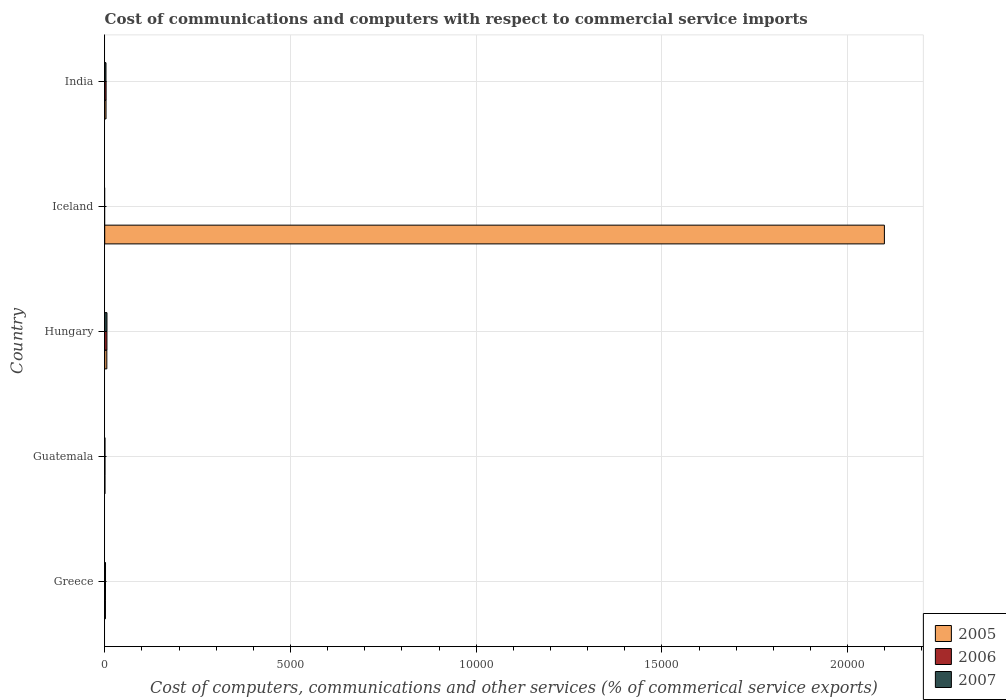How many different coloured bars are there?
Your response must be concise. 3. What is the label of the 3rd group of bars from the top?
Make the answer very short. Hungary. In how many cases, is the number of bars for a given country not equal to the number of legend labels?
Your answer should be compact. 1. What is the cost of communications and computers in 2005 in Greece?
Ensure brevity in your answer.  19.54. Across all countries, what is the maximum cost of communications and computers in 2007?
Provide a short and direct response. 60.46. Across all countries, what is the minimum cost of communications and computers in 2005?
Provide a succinct answer. 5.89. In which country was the cost of communications and computers in 2007 maximum?
Your answer should be very brief. Hungary. What is the total cost of communications and computers in 2005 in the graph?
Keep it short and to the point. 2.11e+04. What is the difference between the cost of communications and computers in 2007 in Greece and that in India?
Provide a succinct answer. -12.91. What is the difference between the cost of communications and computers in 2005 in India and the cost of communications and computers in 2007 in Greece?
Make the answer very short. 13.91. What is the average cost of communications and computers in 2007 per country?
Provide a succinct answer. 24.45. What is the difference between the cost of communications and computers in 2006 and cost of communications and computers in 2005 in Hungary?
Give a very brief answer. 3.06. What is the ratio of the cost of communications and computers in 2005 in Hungary to that in Iceland?
Your answer should be compact. 0. Is the cost of communications and computers in 2005 in Iceland less than that in India?
Offer a very short reply. No. Is the difference between the cost of communications and computers in 2006 in Greece and Hungary greater than the difference between the cost of communications and computers in 2005 in Greece and Hungary?
Provide a short and direct response. No. What is the difference between the highest and the second highest cost of communications and computers in 2006?
Your answer should be very brief. 22.77. What is the difference between the highest and the lowest cost of communications and computers in 2007?
Your response must be concise. 60.46. In how many countries, is the cost of communications and computers in 2007 greater than the average cost of communications and computers in 2007 taken over all countries?
Make the answer very short. 2. Is the sum of the cost of communications and computers in 2006 in Greece and India greater than the maximum cost of communications and computers in 2005 across all countries?
Ensure brevity in your answer.  No. Are all the bars in the graph horizontal?
Your answer should be compact. Yes. What is the difference between two consecutive major ticks on the X-axis?
Make the answer very short. 5000. Does the graph contain any zero values?
Your answer should be compact. Yes. Does the graph contain grids?
Offer a terse response. Yes. Where does the legend appear in the graph?
Your answer should be very brief. Bottom right. How are the legend labels stacked?
Your response must be concise. Vertical. What is the title of the graph?
Give a very brief answer. Cost of communications and computers with respect to commercial service imports. What is the label or title of the X-axis?
Offer a terse response. Cost of computers, communications and other services (% of commerical service exports). What is the label or title of the Y-axis?
Keep it short and to the point. Country. What is the Cost of computers, communications and other services (% of commerical service exports) in 2005 in Greece?
Offer a very short reply. 19.54. What is the Cost of computers, communications and other services (% of commerical service exports) in 2006 in Greece?
Keep it short and to the point. 20.81. What is the Cost of computers, communications and other services (% of commerical service exports) of 2007 in Greece?
Make the answer very short. 21.27. What is the Cost of computers, communications and other services (% of commerical service exports) of 2005 in Guatemala?
Give a very brief answer. 5.89. What is the Cost of computers, communications and other services (% of commerical service exports) of 2006 in Guatemala?
Provide a succinct answer. 6.58. What is the Cost of computers, communications and other services (% of commerical service exports) in 2007 in Guatemala?
Your answer should be compact. 6.34. What is the Cost of computers, communications and other services (% of commerical service exports) in 2005 in Hungary?
Your response must be concise. 56.61. What is the Cost of computers, communications and other services (% of commerical service exports) in 2006 in Hungary?
Offer a terse response. 59.67. What is the Cost of computers, communications and other services (% of commerical service exports) of 2007 in Hungary?
Offer a terse response. 60.46. What is the Cost of computers, communications and other services (% of commerical service exports) of 2005 in Iceland?
Your response must be concise. 2.10e+04. What is the Cost of computers, communications and other services (% of commerical service exports) in 2006 in Iceland?
Make the answer very short. 0. What is the Cost of computers, communications and other services (% of commerical service exports) in 2007 in Iceland?
Provide a succinct answer. 0. What is the Cost of computers, communications and other services (% of commerical service exports) in 2005 in India?
Your answer should be compact. 35.18. What is the Cost of computers, communications and other services (% of commerical service exports) in 2006 in India?
Provide a succinct answer. 36.9. What is the Cost of computers, communications and other services (% of commerical service exports) of 2007 in India?
Give a very brief answer. 34.18. Across all countries, what is the maximum Cost of computers, communications and other services (% of commerical service exports) of 2005?
Offer a terse response. 2.10e+04. Across all countries, what is the maximum Cost of computers, communications and other services (% of commerical service exports) in 2006?
Make the answer very short. 59.67. Across all countries, what is the maximum Cost of computers, communications and other services (% of commerical service exports) of 2007?
Your answer should be very brief. 60.46. Across all countries, what is the minimum Cost of computers, communications and other services (% of commerical service exports) in 2005?
Provide a succinct answer. 5.89. What is the total Cost of computers, communications and other services (% of commerical service exports) of 2005 in the graph?
Offer a terse response. 2.11e+04. What is the total Cost of computers, communications and other services (% of commerical service exports) of 2006 in the graph?
Offer a terse response. 123.96. What is the total Cost of computers, communications and other services (% of commerical service exports) of 2007 in the graph?
Keep it short and to the point. 122.25. What is the difference between the Cost of computers, communications and other services (% of commerical service exports) of 2005 in Greece and that in Guatemala?
Your answer should be very brief. 13.65. What is the difference between the Cost of computers, communications and other services (% of commerical service exports) in 2006 in Greece and that in Guatemala?
Provide a succinct answer. 14.23. What is the difference between the Cost of computers, communications and other services (% of commerical service exports) in 2007 in Greece and that in Guatemala?
Provide a short and direct response. 14.93. What is the difference between the Cost of computers, communications and other services (% of commerical service exports) in 2005 in Greece and that in Hungary?
Make the answer very short. -37.06. What is the difference between the Cost of computers, communications and other services (% of commerical service exports) of 2006 in Greece and that in Hungary?
Ensure brevity in your answer.  -38.86. What is the difference between the Cost of computers, communications and other services (% of commerical service exports) in 2007 in Greece and that in Hungary?
Keep it short and to the point. -39.19. What is the difference between the Cost of computers, communications and other services (% of commerical service exports) of 2005 in Greece and that in Iceland?
Ensure brevity in your answer.  -2.10e+04. What is the difference between the Cost of computers, communications and other services (% of commerical service exports) in 2005 in Greece and that in India?
Keep it short and to the point. -15.63. What is the difference between the Cost of computers, communications and other services (% of commerical service exports) in 2006 in Greece and that in India?
Ensure brevity in your answer.  -16.09. What is the difference between the Cost of computers, communications and other services (% of commerical service exports) of 2007 in Greece and that in India?
Keep it short and to the point. -12.91. What is the difference between the Cost of computers, communications and other services (% of commerical service exports) of 2005 in Guatemala and that in Hungary?
Your response must be concise. -50.71. What is the difference between the Cost of computers, communications and other services (% of commerical service exports) in 2006 in Guatemala and that in Hungary?
Provide a succinct answer. -53.09. What is the difference between the Cost of computers, communications and other services (% of commerical service exports) of 2007 in Guatemala and that in Hungary?
Offer a very short reply. -54.13. What is the difference between the Cost of computers, communications and other services (% of commerical service exports) in 2005 in Guatemala and that in Iceland?
Make the answer very short. -2.10e+04. What is the difference between the Cost of computers, communications and other services (% of commerical service exports) in 2005 in Guatemala and that in India?
Your answer should be very brief. -29.28. What is the difference between the Cost of computers, communications and other services (% of commerical service exports) in 2006 in Guatemala and that in India?
Make the answer very short. -30.32. What is the difference between the Cost of computers, communications and other services (% of commerical service exports) of 2007 in Guatemala and that in India?
Give a very brief answer. -27.85. What is the difference between the Cost of computers, communications and other services (% of commerical service exports) of 2005 in Hungary and that in Iceland?
Offer a very short reply. -2.09e+04. What is the difference between the Cost of computers, communications and other services (% of commerical service exports) in 2005 in Hungary and that in India?
Offer a terse response. 21.43. What is the difference between the Cost of computers, communications and other services (% of commerical service exports) of 2006 in Hungary and that in India?
Give a very brief answer. 22.77. What is the difference between the Cost of computers, communications and other services (% of commerical service exports) of 2007 in Hungary and that in India?
Ensure brevity in your answer.  26.28. What is the difference between the Cost of computers, communications and other services (% of commerical service exports) of 2005 in Iceland and that in India?
Give a very brief answer. 2.10e+04. What is the difference between the Cost of computers, communications and other services (% of commerical service exports) of 2005 in Greece and the Cost of computers, communications and other services (% of commerical service exports) of 2006 in Guatemala?
Your answer should be compact. 12.96. What is the difference between the Cost of computers, communications and other services (% of commerical service exports) in 2005 in Greece and the Cost of computers, communications and other services (% of commerical service exports) in 2007 in Guatemala?
Ensure brevity in your answer.  13.21. What is the difference between the Cost of computers, communications and other services (% of commerical service exports) in 2006 in Greece and the Cost of computers, communications and other services (% of commerical service exports) in 2007 in Guatemala?
Provide a short and direct response. 14.47. What is the difference between the Cost of computers, communications and other services (% of commerical service exports) in 2005 in Greece and the Cost of computers, communications and other services (% of commerical service exports) in 2006 in Hungary?
Ensure brevity in your answer.  -40.13. What is the difference between the Cost of computers, communications and other services (% of commerical service exports) of 2005 in Greece and the Cost of computers, communications and other services (% of commerical service exports) of 2007 in Hungary?
Keep it short and to the point. -40.92. What is the difference between the Cost of computers, communications and other services (% of commerical service exports) of 2006 in Greece and the Cost of computers, communications and other services (% of commerical service exports) of 2007 in Hungary?
Your response must be concise. -39.65. What is the difference between the Cost of computers, communications and other services (% of commerical service exports) of 2005 in Greece and the Cost of computers, communications and other services (% of commerical service exports) of 2006 in India?
Ensure brevity in your answer.  -17.35. What is the difference between the Cost of computers, communications and other services (% of commerical service exports) in 2005 in Greece and the Cost of computers, communications and other services (% of commerical service exports) in 2007 in India?
Offer a terse response. -14.64. What is the difference between the Cost of computers, communications and other services (% of commerical service exports) in 2006 in Greece and the Cost of computers, communications and other services (% of commerical service exports) in 2007 in India?
Offer a very short reply. -13.37. What is the difference between the Cost of computers, communications and other services (% of commerical service exports) in 2005 in Guatemala and the Cost of computers, communications and other services (% of commerical service exports) in 2006 in Hungary?
Provide a succinct answer. -53.78. What is the difference between the Cost of computers, communications and other services (% of commerical service exports) of 2005 in Guatemala and the Cost of computers, communications and other services (% of commerical service exports) of 2007 in Hungary?
Your answer should be very brief. -54.57. What is the difference between the Cost of computers, communications and other services (% of commerical service exports) of 2006 in Guatemala and the Cost of computers, communications and other services (% of commerical service exports) of 2007 in Hungary?
Keep it short and to the point. -53.88. What is the difference between the Cost of computers, communications and other services (% of commerical service exports) of 2005 in Guatemala and the Cost of computers, communications and other services (% of commerical service exports) of 2006 in India?
Make the answer very short. -31. What is the difference between the Cost of computers, communications and other services (% of commerical service exports) in 2005 in Guatemala and the Cost of computers, communications and other services (% of commerical service exports) in 2007 in India?
Offer a terse response. -28.29. What is the difference between the Cost of computers, communications and other services (% of commerical service exports) in 2006 in Guatemala and the Cost of computers, communications and other services (% of commerical service exports) in 2007 in India?
Your answer should be very brief. -27.6. What is the difference between the Cost of computers, communications and other services (% of commerical service exports) of 2005 in Hungary and the Cost of computers, communications and other services (% of commerical service exports) of 2006 in India?
Keep it short and to the point. 19.71. What is the difference between the Cost of computers, communications and other services (% of commerical service exports) of 2005 in Hungary and the Cost of computers, communications and other services (% of commerical service exports) of 2007 in India?
Make the answer very short. 22.42. What is the difference between the Cost of computers, communications and other services (% of commerical service exports) of 2006 in Hungary and the Cost of computers, communications and other services (% of commerical service exports) of 2007 in India?
Offer a very short reply. 25.49. What is the difference between the Cost of computers, communications and other services (% of commerical service exports) of 2005 in Iceland and the Cost of computers, communications and other services (% of commerical service exports) of 2006 in India?
Your answer should be very brief. 2.10e+04. What is the difference between the Cost of computers, communications and other services (% of commerical service exports) of 2005 in Iceland and the Cost of computers, communications and other services (% of commerical service exports) of 2007 in India?
Provide a succinct answer. 2.10e+04. What is the average Cost of computers, communications and other services (% of commerical service exports) of 2005 per country?
Make the answer very short. 4221.54. What is the average Cost of computers, communications and other services (% of commerical service exports) of 2006 per country?
Your answer should be compact. 24.79. What is the average Cost of computers, communications and other services (% of commerical service exports) in 2007 per country?
Your answer should be very brief. 24.45. What is the difference between the Cost of computers, communications and other services (% of commerical service exports) in 2005 and Cost of computers, communications and other services (% of commerical service exports) in 2006 in Greece?
Offer a terse response. -1.27. What is the difference between the Cost of computers, communications and other services (% of commerical service exports) of 2005 and Cost of computers, communications and other services (% of commerical service exports) of 2007 in Greece?
Give a very brief answer. -1.73. What is the difference between the Cost of computers, communications and other services (% of commerical service exports) of 2006 and Cost of computers, communications and other services (% of commerical service exports) of 2007 in Greece?
Your answer should be compact. -0.46. What is the difference between the Cost of computers, communications and other services (% of commerical service exports) of 2005 and Cost of computers, communications and other services (% of commerical service exports) of 2006 in Guatemala?
Keep it short and to the point. -0.69. What is the difference between the Cost of computers, communications and other services (% of commerical service exports) in 2005 and Cost of computers, communications and other services (% of commerical service exports) in 2007 in Guatemala?
Your answer should be compact. -0.44. What is the difference between the Cost of computers, communications and other services (% of commerical service exports) in 2006 and Cost of computers, communications and other services (% of commerical service exports) in 2007 in Guatemala?
Provide a short and direct response. 0.25. What is the difference between the Cost of computers, communications and other services (% of commerical service exports) of 2005 and Cost of computers, communications and other services (% of commerical service exports) of 2006 in Hungary?
Make the answer very short. -3.06. What is the difference between the Cost of computers, communications and other services (% of commerical service exports) in 2005 and Cost of computers, communications and other services (% of commerical service exports) in 2007 in Hungary?
Your answer should be very brief. -3.86. What is the difference between the Cost of computers, communications and other services (% of commerical service exports) of 2006 and Cost of computers, communications and other services (% of commerical service exports) of 2007 in Hungary?
Ensure brevity in your answer.  -0.79. What is the difference between the Cost of computers, communications and other services (% of commerical service exports) of 2005 and Cost of computers, communications and other services (% of commerical service exports) of 2006 in India?
Keep it short and to the point. -1.72. What is the difference between the Cost of computers, communications and other services (% of commerical service exports) of 2005 and Cost of computers, communications and other services (% of commerical service exports) of 2007 in India?
Your response must be concise. 0.99. What is the difference between the Cost of computers, communications and other services (% of commerical service exports) of 2006 and Cost of computers, communications and other services (% of commerical service exports) of 2007 in India?
Give a very brief answer. 2.71. What is the ratio of the Cost of computers, communications and other services (% of commerical service exports) of 2005 in Greece to that in Guatemala?
Your response must be concise. 3.32. What is the ratio of the Cost of computers, communications and other services (% of commerical service exports) in 2006 in Greece to that in Guatemala?
Ensure brevity in your answer.  3.16. What is the ratio of the Cost of computers, communications and other services (% of commerical service exports) in 2007 in Greece to that in Guatemala?
Provide a short and direct response. 3.36. What is the ratio of the Cost of computers, communications and other services (% of commerical service exports) of 2005 in Greece to that in Hungary?
Provide a short and direct response. 0.35. What is the ratio of the Cost of computers, communications and other services (% of commerical service exports) in 2006 in Greece to that in Hungary?
Offer a very short reply. 0.35. What is the ratio of the Cost of computers, communications and other services (% of commerical service exports) in 2007 in Greece to that in Hungary?
Your answer should be very brief. 0.35. What is the ratio of the Cost of computers, communications and other services (% of commerical service exports) of 2005 in Greece to that in Iceland?
Your answer should be compact. 0. What is the ratio of the Cost of computers, communications and other services (% of commerical service exports) in 2005 in Greece to that in India?
Offer a very short reply. 0.56. What is the ratio of the Cost of computers, communications and other services (% of commerical service exports) in 2006 in Greece to that in India?
Your answer should be very brief. 0.56. What is the ratio of the Cost of computers, communications and other services (% of commerical service exports) in 2007 in Greece to that in India?
Your answer should be compact. 0.62. What is the ratio of the Cost of computers, communications and other services (% of commerical service exports) of 2005 in Guatemala to that in Hungary?
Your answer should be very brief. 0.1. What is the ratio of the Cost of computers, communications and other services (% of commerical service exports) of 2006 in Guatemala to that in Hungary?
Make the answer very short. 0.11. What is the ratio of the Cost of computers, communications and other services (% of commerical service exports) in 2007 in Guatemala to that in Hungary?
Ensure brevity in your answer.  0.1. What is the ratio of the Cost of computers, communications and other services (% of commerical service exports) of 2005 in Guatemala to that in Iceland?
Your answer should be compact. 0. What is the ratio of the Cost of computers, communications and other services (% of commerical service exports) in 2005 in Guatemala to that in India?
Your answer should be compact. 0.17. What is the ratio of the Cost of computers, communications and other services (% of commerical service exports) in 2006 in Guatemala to that in India?
Provide a short and direct response. 0.18. What is the ratio of the Cost of computers, communications and other services (% of commerical service exports) of 2007 in Guatemala to that in India?
Your answer should be very brief. 0.19. What is the ratio of the Cost of computers, communications and other services (% of commerical service exports) in 2005 in Hungary to that in Iceland?
Give a very brief answer. 0. What is the ratio of the Cost of computers, communications and other services (% of commerical service exports) in 2005 in Hungary to that in India?
Ensure brevity in your answer.  1.61. What is the ratio of the Cost of computers, communications and other services (% of commerical service exports) of 2006 in Hungary to that in India?
Provide a short and direct response. 1.62. What is the ratio of the Cost of computers, communications and other services (% of commerical service exports) in 2007 in Hungary to that in India?
Your answer should be compact. 1.77. What is the ratio of the Cost of computers, communications and other services (% of commerical service exports) of 2005 in Iceland to that in India?
Offer a very short reply. 596.72. What is the difference between the highest and the second highest Cost of computers, communications and other services (% of commerical service exports) of 2005?
Your answer should be compact. 2.09e+04. What is the difference between the highest and the second highest Cost of computers, communications and other services (% of commerical service exports) in 2006?
Your answer should be compact. 22.77. What is the difference between the highest and the second highest Cost of computers, communications and other services (% of commerical service exports) of 2007?
Offer a terse response. 26.28. What is the difference between the highest and the lowest Cost of computers, communications and other services (% of commerical service exports) in 2005?
Your answer should be very brief. 2.10e+04. What is the difference between the highest and the lowest Cost of computers, communications and other services (% of commerical service exports) of 2006?
Offer a terse response. 59.67. What is the difference between the highest and the lowest Cost of computers, communications and other services (% of commerical service exports) of 2007?
Keep it short and to the point. 60.46. 